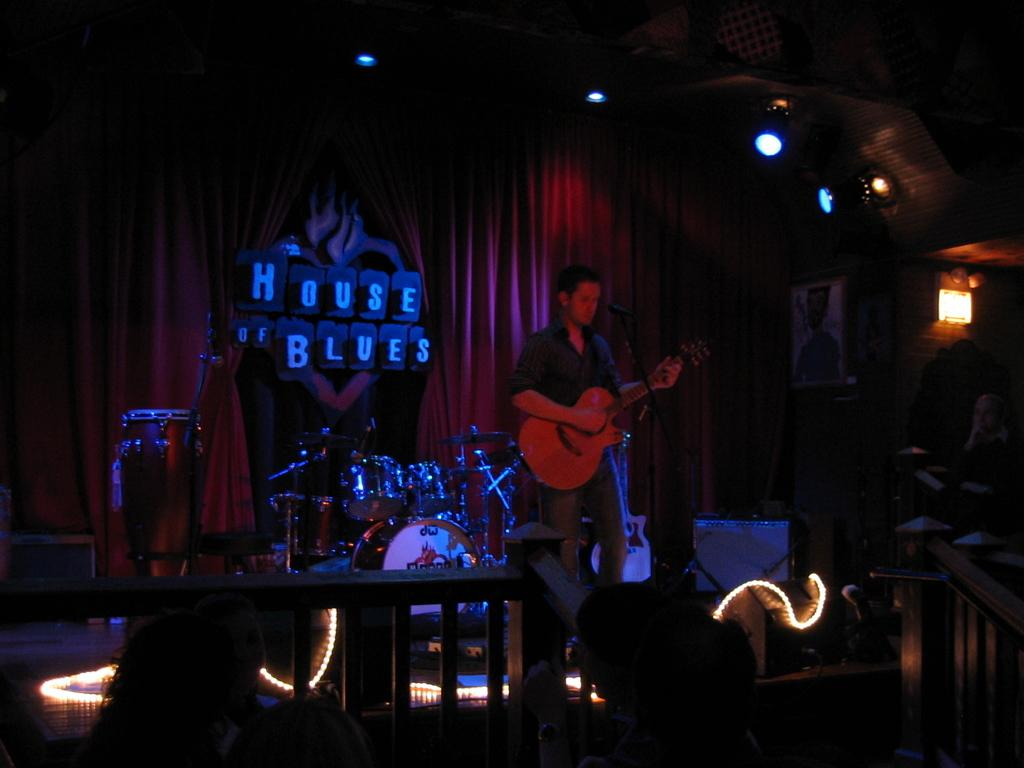What is the person in the image doing? The person is playing a guitar. What is the person standing near in the image? The person is standing in front of a microphone. What can be seen in the image that might be used for lighting? There are focusing lights in the image. What type of background is visible in the image? There is a red curtain in the image. What other musical instruments can be seen in the image? There are musical instruments in the image. What is on the wall in the image? There is a picture on the wall in the image. What type of grain is visible on the person's vest in the image? There is no vest or grain present in the image. What reason does the person have for playing the guitar in the image? The image does not provide any information about the person's reason for playing the guitar. 